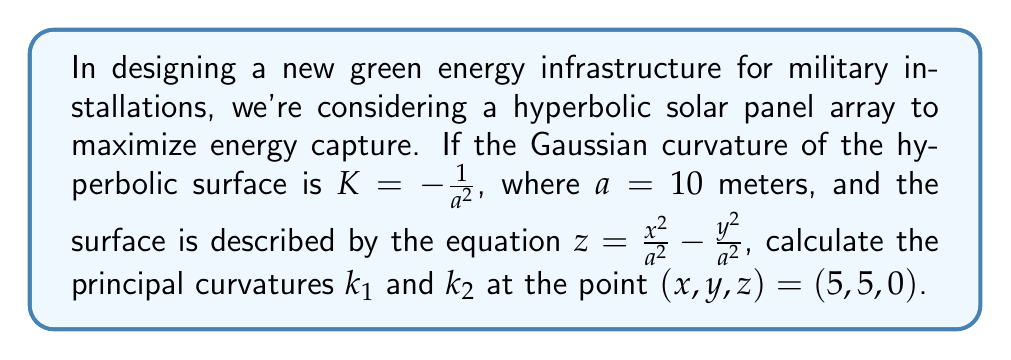Give your solution to this math problem. To solve this problem, we'll follow these steps:

1) Recall that for a hyperbolic surface, the Gaussian curvature $K$ is the product of the principal curvatures:

   $K = k_1 \cdot k_2 = -\frac{1}{a^2}$

2) For a surface described by $z = f(x,y)$, the principal curvatures are given by:

   $k_{1,2} = H \pm \sqrt{H^2 - K}$

   where $H$ is the mean curvature.

3) For our surface $z = \frac{x^2}{a^2} - \frac{y^2}{a^2}$, we can calculate:

   $f_x = \frac{2x}{a^2}$, $f_y = -\frac{2y}{a^2}$
   $f_{xx} = \frac{2}{a^2}$, $f_{yy} = -\frac{2}{a^2}$, $f_{xy} = 0$

4) The mean curvature $H$ is given by:

   $H = \frac{(1+f_y^2)f_{xx} - 2f_xf_yf_{xy} + (1+f_x^2)f_{yy}}{2(1+f_x^2+f_y^2)^{3/2}}$

5) At the point (5, 5, 0):

   $f_x = f_y = \frac{1}{a} = 0.1$
   $f_{xx} = -f_{yy} = \frac{2}{a^2} = 0.02$
   $f_{xy} = 0$

6) Substituting into the mean curvature formula:

   $H = \frac{(1+0.1^2)(0.02) - 2(0.1)(0.1)(0) + (1+0.1^2)(-0.02)}{2(1+0.1^2+0.1^2)^{3/2}} = 0$

7) Now we can calculate the principal curvatures:

   $k_{1,2} = H \pm \sqrt{H^2 - K} = 0 \pm \sqrt{0^2 - (-\frac{1}{100})} = \pm \frac{1}{10}$

Therefore, $k_1 = \frac{1}{10}$ and $k_2 = -\frac{1}{10}$.
Answer: $k_1 = \frac{1}{10}$, $k_2 = -\frac{1}{10}$ 